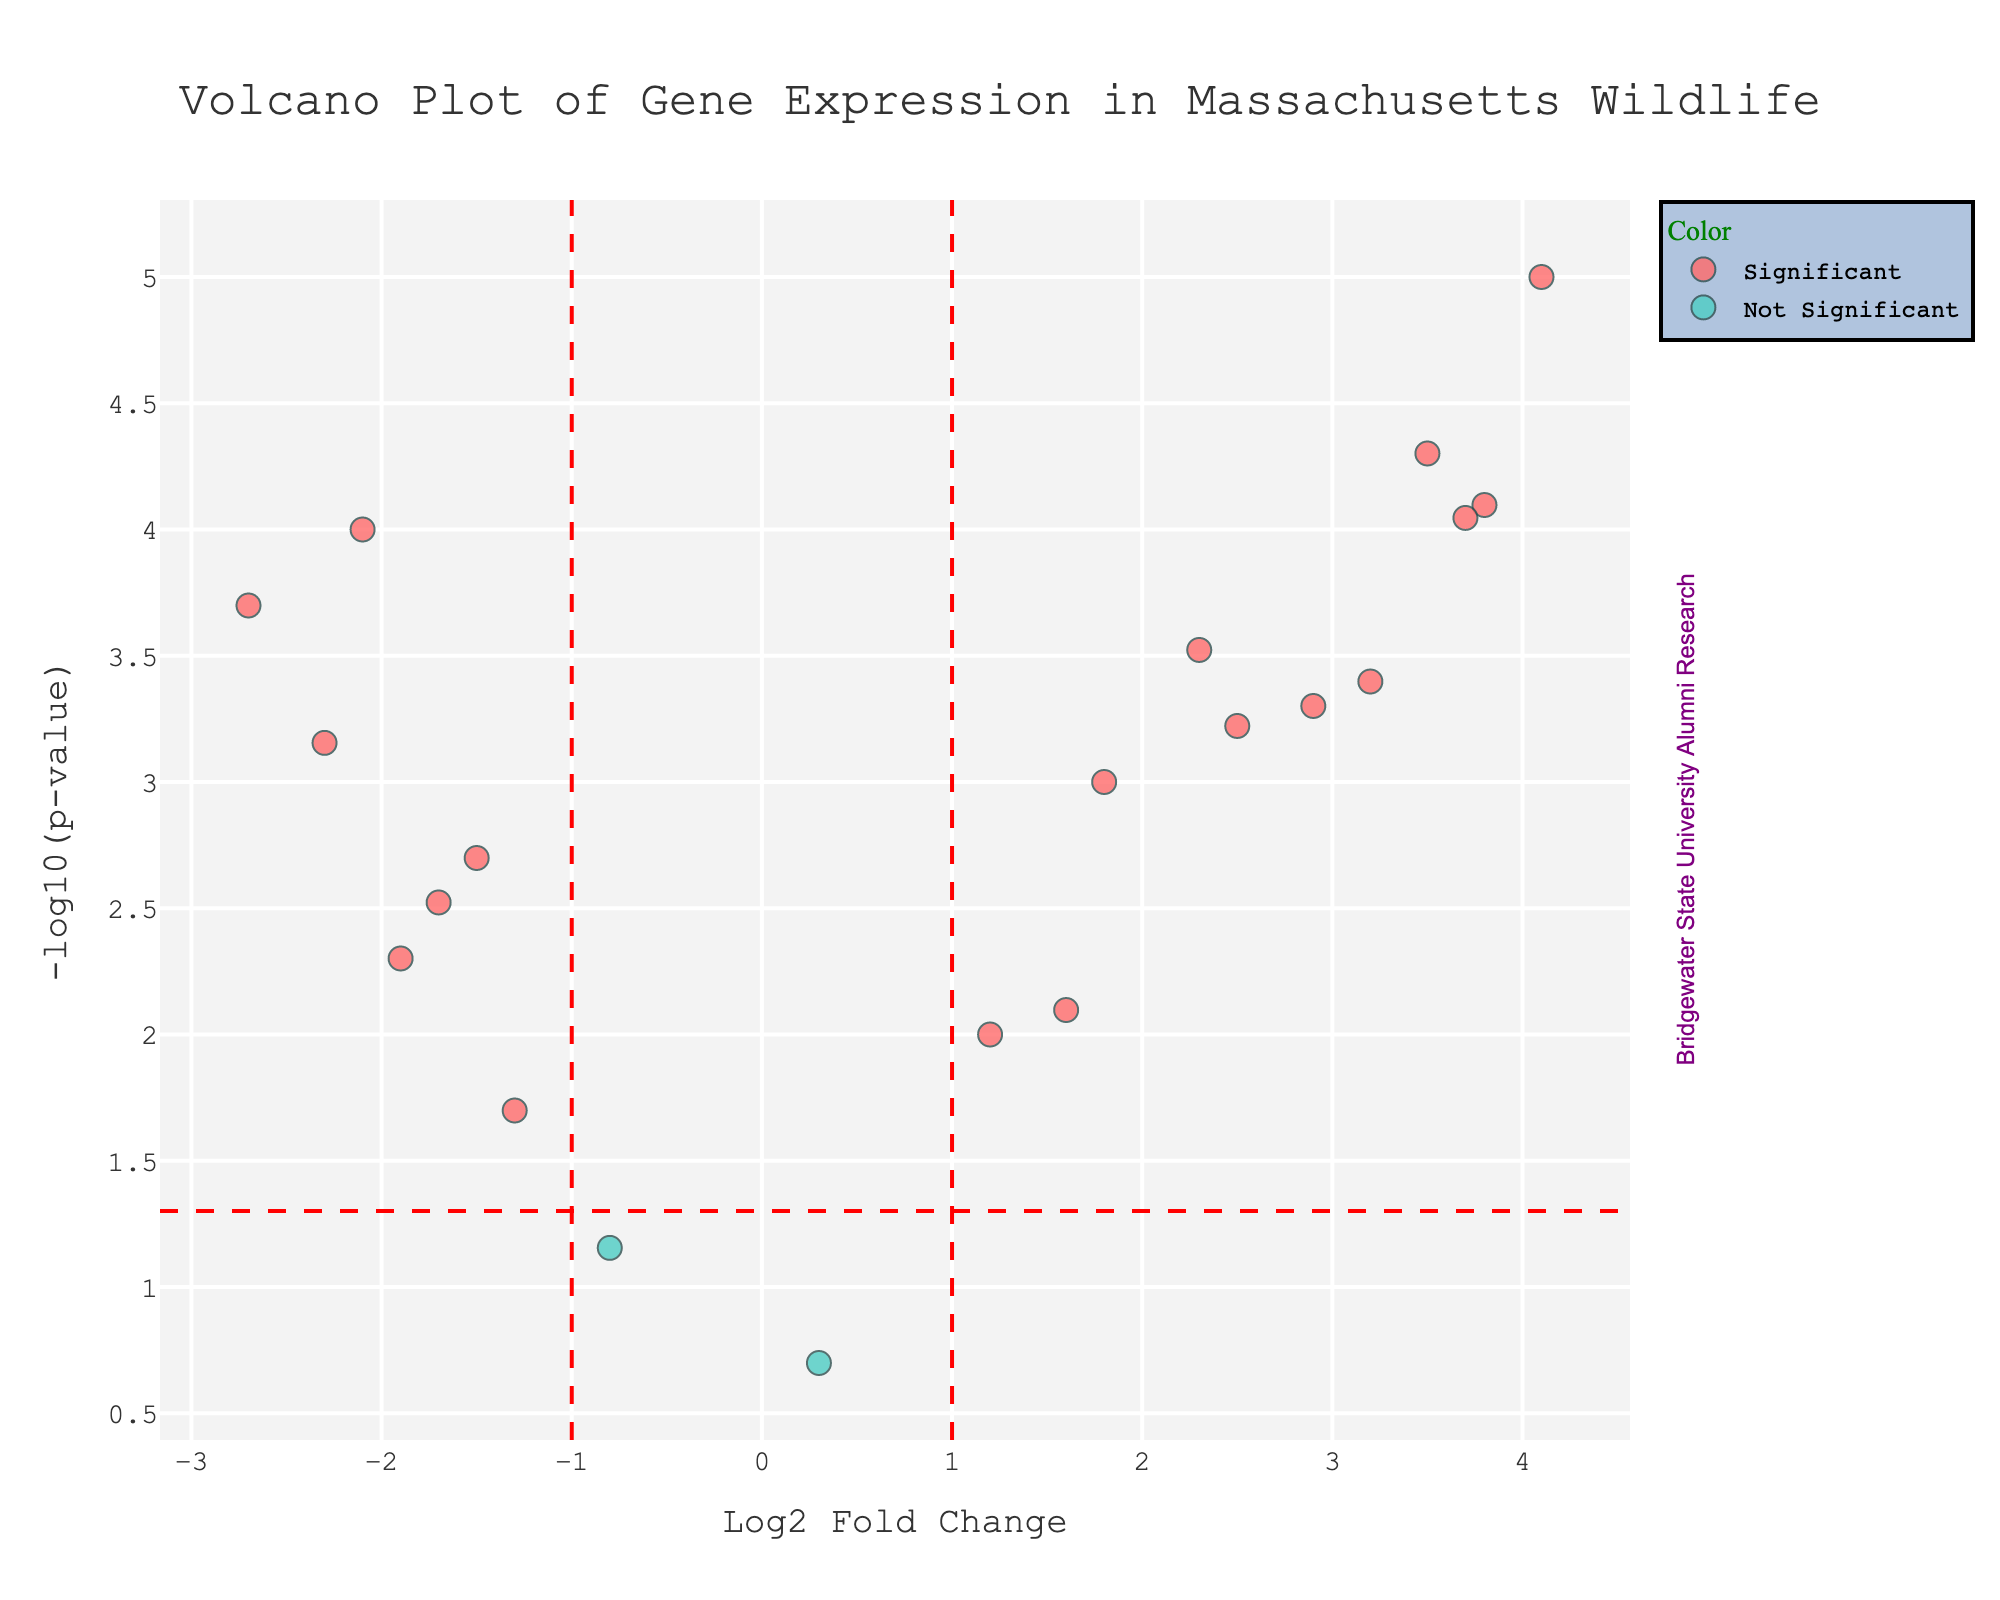What is the title of the plot? The title is usually located at the top of the plot and provides a description of what the plot represents, in this case, detailing gene expression in Massachusetts wildlife.
Answer: Volcano Plot of Gene Expression in Massachusetts Wildlife What is the x-axis labeled? The x-axis label describes what variable is being represented along the horizontal axis; in this plot, it shows the fold change in gene expression in logarithmic base 2 scale.
Answer: Log2 Fold Change What information is represented by the y-axis? The y-axis label indicates the variable plotted along the vertical axis; here, it represents the negative logarithm (base 10) of the p-value, which helps in highlighting statistical significance.
Answer: -log10(p-value) Which gene has the highest positive Log2 Fold Change? By locating the data point farthest to the right, you can identify the gene with the maximum positive fold change, which means it is highly upregulated. The hover information typically includes the gene name.
Answer: IL6 How many genes are classified as significant based on the plot? Genes classified as significant are usually indicated by a distinct color. Count the number of points with the color representing significant genes.
Answer: 14 What Log2 Fold Change threshold was used to determine significance? Threshold lines in the plot usually indicate the criteria for significance; the vertical threshold lines show the Log2 Fold Change cutoff.
Answer: ±1 Which gene is marked with the lowest p-value? The lowest p-value means the highest -log10(p-value) on the plot. Locate the data point highest up on the y-axis and note its corresponding gene.
Answer: IL6 What color is used to represent significant genes in this plot? Observing the plot's legend or the colors of the data points will help identify the specific color representing significant genes.
Answer: Red Among the significant genes, which has the lowest negative Log2 Fold Change? Locate the significant data point farthest to the left to identify the gene with the lowest negative fold change, indicating strong downregulation.
Answer: TNF Which gene lies closest to the zero point on the x-axis yet still upregulated? Find the gene that is closest to zero Log2 Fold Change on the positive side while remaining above the p-value significance threshold line.
Answer: CLOCK 